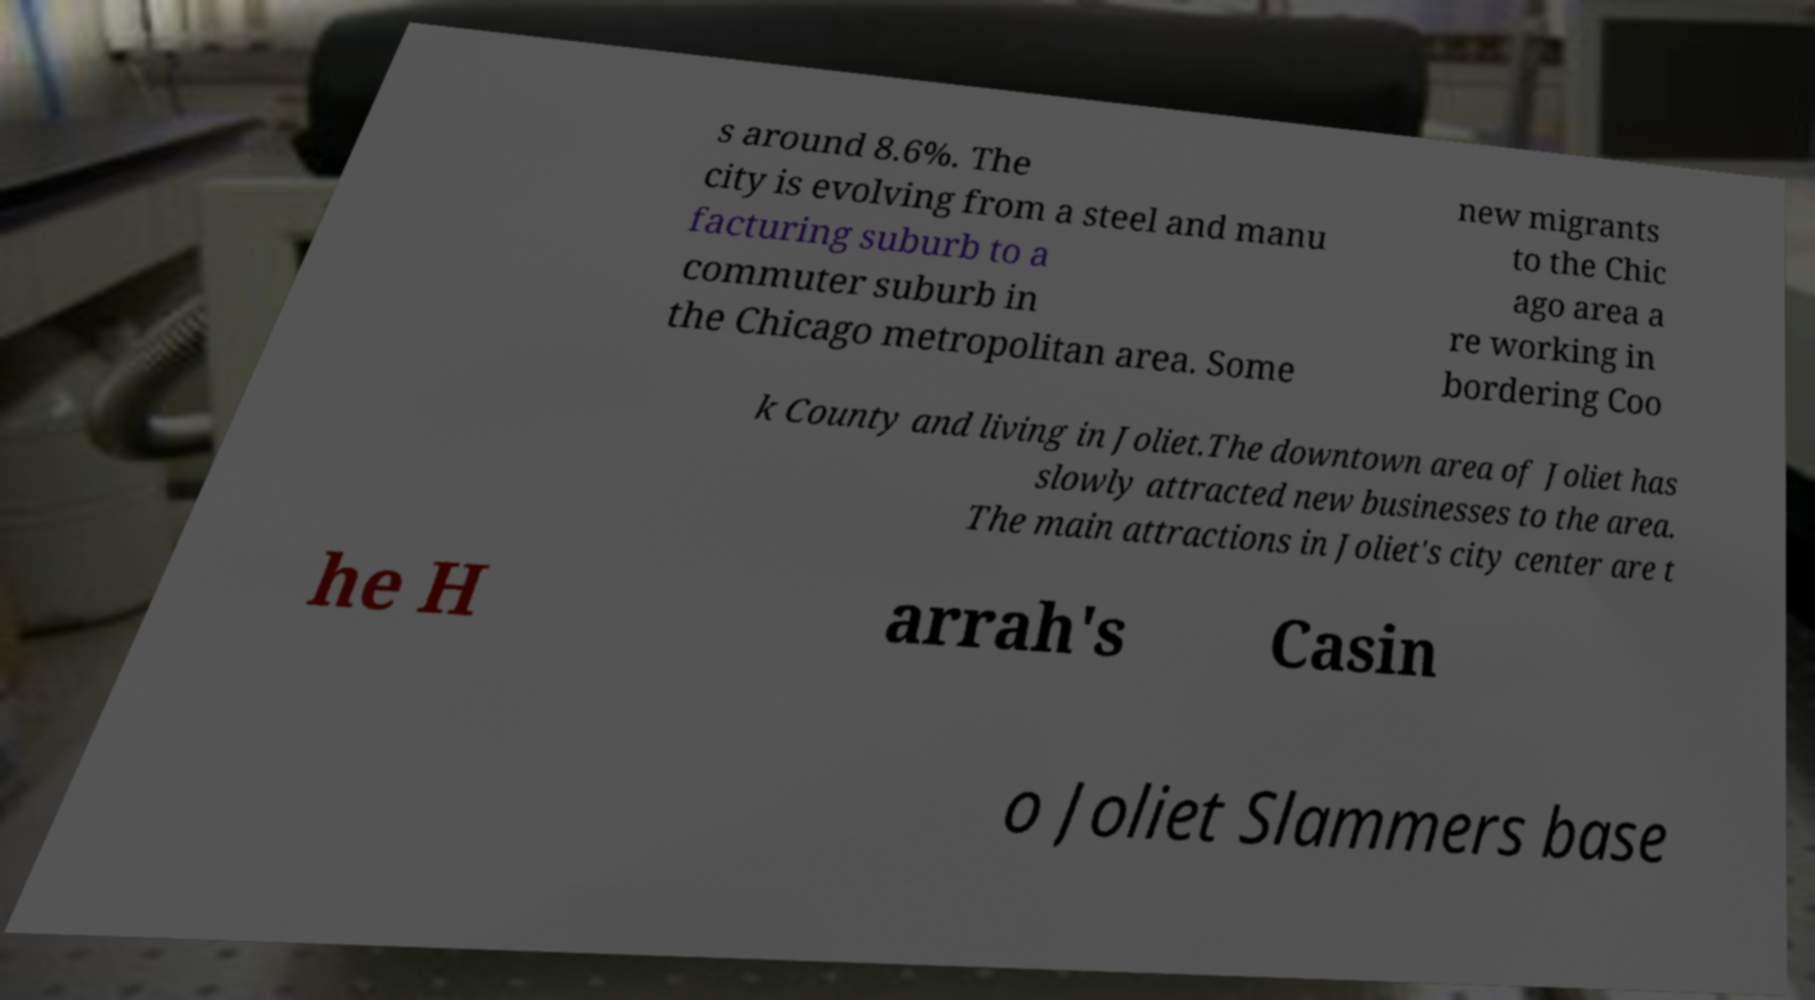For documentation purposes, I need the text within this image transcribed. Could you provide that? s around 8.6%. The city is evolving from a steel and manu facturing suburb to a commuter suburb in the Chicago metropolitan area. Some new migrants to the Chic ago area a re working in bordering Coo k County and living in Joliet.The downtown area of Joliet has slowly attracted new businesses to the area. The main attractions in Joliet's city center are t he H arrah's Casin o Joliet Slammers base 